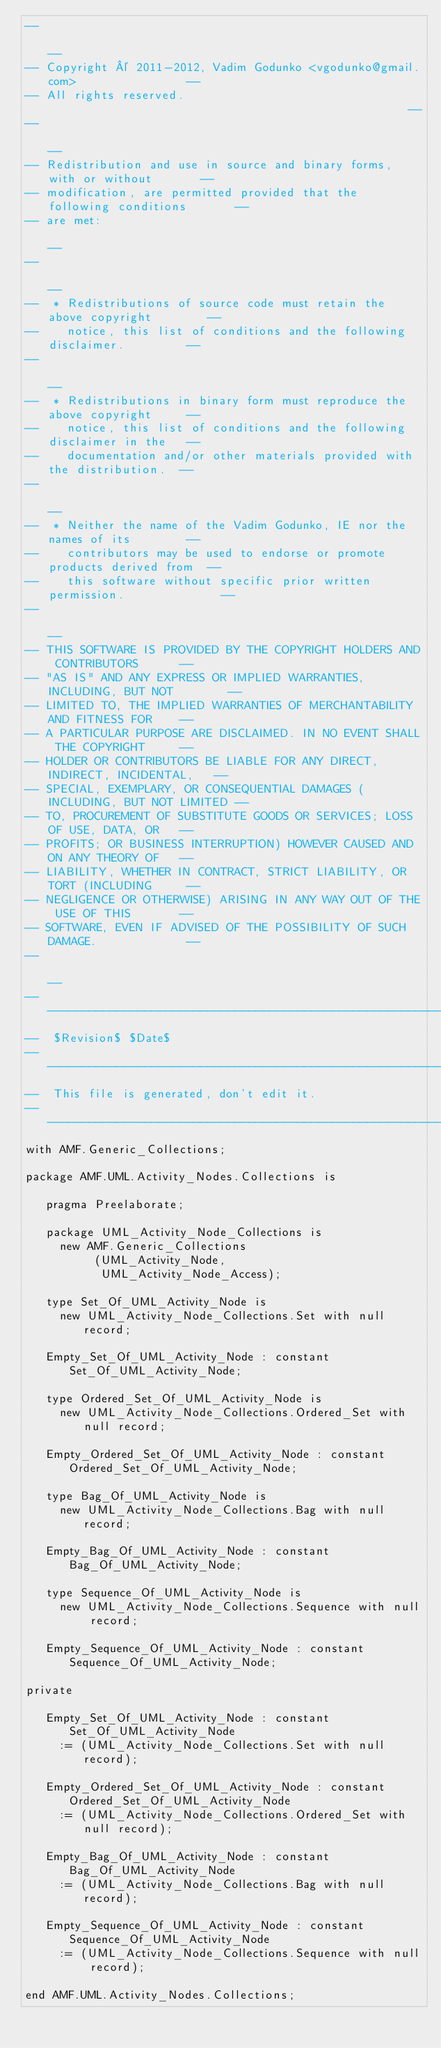Convert code to text. <code><loc_0><loc_0><loc_500><loc_500><_Ada_>--                                                                          --
-- Copyright © 2011-2012, Vadim Godunko <vgodunko@gmail.com>                --
-- All rights reserved.                                                     --
--                                                                          --
-- Redistribution and use in source and binary forms, with or without       --
-- modification, are permitted provided that the following conditions       --
-- are met:                                                                 --
--                                                                          --
--  * Redistributions of source code must retain the above copyright        --
--    notice, this list of conditions and the following disclaimer.         --
--                                                                          --
--  * Redistributions in binary form must reproduce the above copyright     --
--    notice, this list of conditions and the following disclaimer in the   --
--    documentation and/or other materials provided with the distribution.  --
--                                                                          --
--  * Neither the name of the Vadim Godunko, IE nor the names of its        --
--    contributors may be used to endorse or promote products derived from  --
--    this software without specific prior written permission.              --
--                                                                          --
-- THIS SOFTWARE IS PROVIDED BY THE COPYRIGHT HOLDERS AND CONTRIBUTORS      --
-- "AS IS" AND ANY EXPRESS OR IMPLIED WARRANTIES, INCLUDING, BUT NOT        --
-- LIMITED TO, THE IMPLIED WARRANTIES OF MERCHANTABILITY AND FITNESS FOR    --
-- A PARTICULAR PURPOSE ARE DISCLAIMED. IN NO EVENT SHALL THE COPYRIGHT     --
-- HOLDER OR CONTRIBUTORS BE LIABLE FOR ANY DIRECT, INDIRECT, INCIDENTAL,   --
-- SPECIAL, EXEMPLARY, OR CONSEQUENTIAL DAMAGES (INCLUDING, BUT NOT LIMITED --
-- TO, PROCUREMENT OF SUBSTITUTE GOODS OR SERVICES; LOSS OF USE, DATA, OR   --
-- PROFITS; OR BUSINESS INTERRUPTION) HOWEVER CAUSED AND ON ANY THEORY OF   --
-- LIABILITY, WHETHER IN CONTRACT, STRICT LIABILITY, OR TORT (INCLUDING     --
-- NEGLIGENCE OR OTHERWISE) ARISING IN ANY WAY OUT OF THE USE OF THIS       --
-- SOFTWARE, EVEN IF ADVISED OF THE POSSIBILITY OF SUCH DAMAGE.             --
--                                                                          --
------------------------------------------------------------------------------
--  $Revision$ $Date$
------------------------------------------------------------------------------
--  This file is generated, don't edit it.
------------------------------------------------------------------------------
with AMF.Generic_Collections;

package AMF.UML.Activity_Nodes.Collections is

   pragma Preelaborate;

   package UML_Activity_Node_Collections is
     new AMF.Generic_Collections
          (UML_Activity_Node,
           UML_Activity_Node_Access);

   type Set_Of_UML_Activity_Node is
     new UML_Activity_Node_Collections.Set with null record;

   Empty_Set_Of_UML_Activity_Node : constant Set_Of_UML_Activity_Node;

   type Ordered_Set_Of_UML_Activity_Node is
     new UML_Activity_Node_Collections.Ordered_Set with null record;

   Empty_Ordered_Set_Of_UML_Activity_Node : constant Ordered_Set_Of_UML_Activity_Node;

   type Bag_Of_UML_Activity_Node is
     new UML_Activity_Node_Collections.Bag with null record;

   Empty_Bag_Of_UML_Activity_Node : constant Bag_Of_UML_Activity_Node;

   type Sequence_Of_UML_Activity_Node is
     new UML_Activity_Node_Collections.Sequence with null record;

   Empty_Sequence_Of_UML_Activity_Node : constant Sequence_Of_UML_Activity_Node;

private

   Empty_Set_Of_UML_Activity_Node : constant Set_Of_UML_Activity_Node
     := (UML_Activity_Node_Collections.Set with null record);

   Empty_Ordered_Set_Of_UML_Activity_Node : constant Ordered_Set_Of_UML_Activity_Node
     := (UML_Activity_Node_Collections.Ordered_Set with null record);

   Empty_Bag_Of_UML_Activity_Node : constant Bag_Of_UML_Activity_Node
     := (UML_Activity_Node_Collections.Bag with null record);

   Empty_Sequence_Of_UML_Activity_Node : constant Sequence_Of_UML_Activity_Node
     := (UML_Activity_Node_Collections.Sequence with null record);

end AMF.UML.Activity_Nodes.Collections;
</code> 